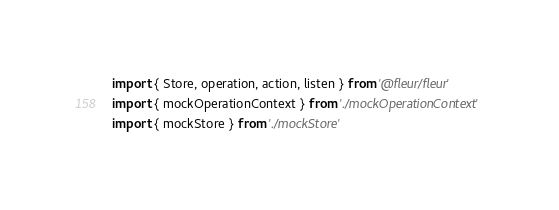Convert code to text. <code><loc_0><loc_0><loc_500><loc_500><_TypeScript_>import { Store, operation, action, listen } from '@fleur/fleur'
import { mockOperationContext } from './mockOperationContext'
import { mockStore } from './mockStore'
</code> 